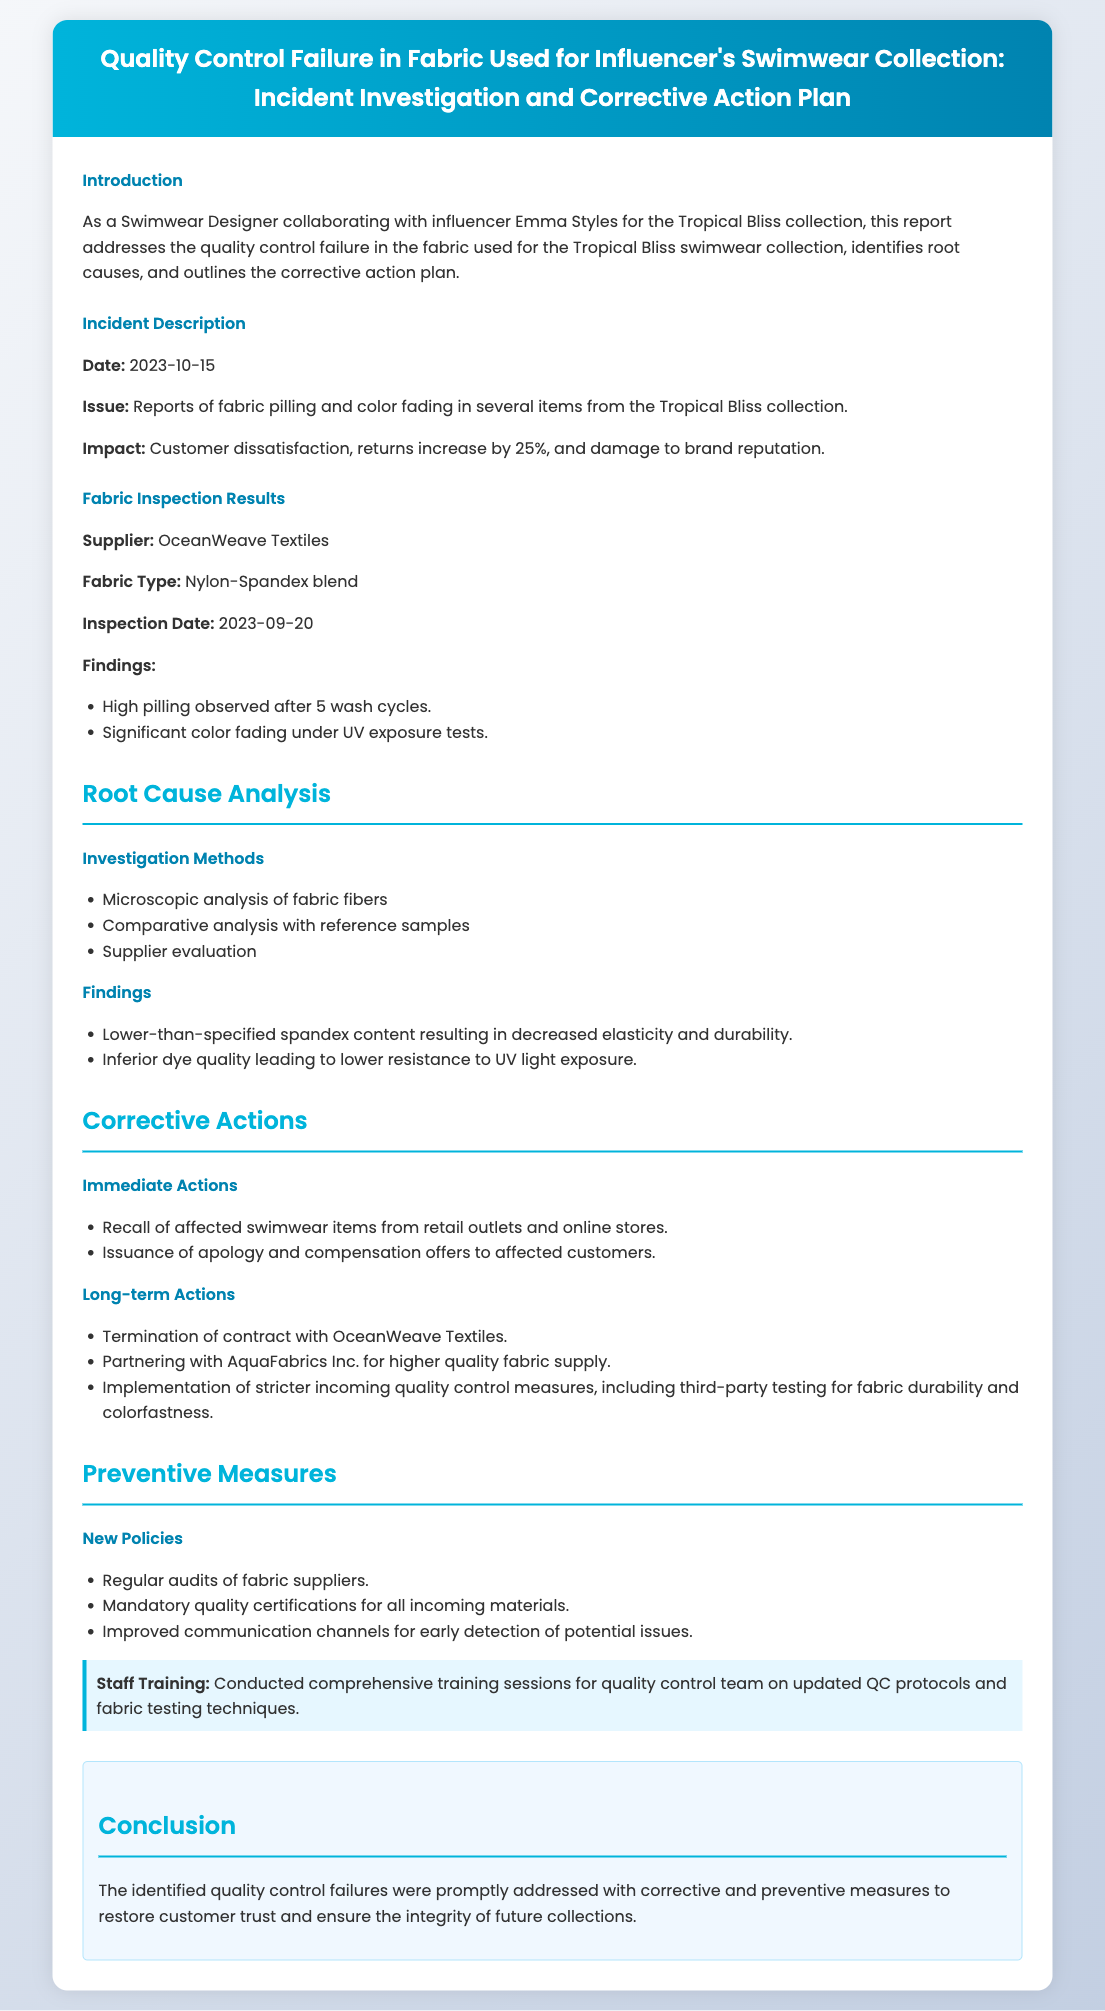what is the date of the incident? The incident date is specified clearly in the document as the date when the quality control failure occurred.
Answer: 2023-10-15 who is the supplier of the fabric? The document lists the fabric supplier responsible for the quality control failure.
Answer: OceanWeave Textiles what was the increase in returns? The report mentions the impact of the quality issue on returns, providing a specific increase percentage.
Answer: 25% what is the fabric type used in the collection? The fabric type is explicitly stated in the inspection results, which gives details about the material used.
Answer: Nylon-Spandex blend what immediate action was taken regarding the swimwear items? The document details the immediate corrective actions taken to address the quality issue, including actions concerning customer interaction.
Answer: Recall of affected swimwear items what are the long-term actions specified in the report? The document outlines essential long-term measures implemented to prevent future quality control failures, including partnership changes.
Answer: Termination of contract with OceanWeave Textiles what training was provided to the staff? The report emphasizes the importance of staff training in relation to quality control measures and protocols.
Answer: Comprehensive training sessions for quality control team what type of analysis was performed during the investigation? The document specifies the types of analyses conducted to identify the root causes of the quality issue.
Answer: Microscopic analysis of fabric fibers what was a significant finding in the root cause analysis? The findings from the root cause analysis reveal critical issues affecting fabric performance for the collections.
Answer: Lower-than-specified spandex content 